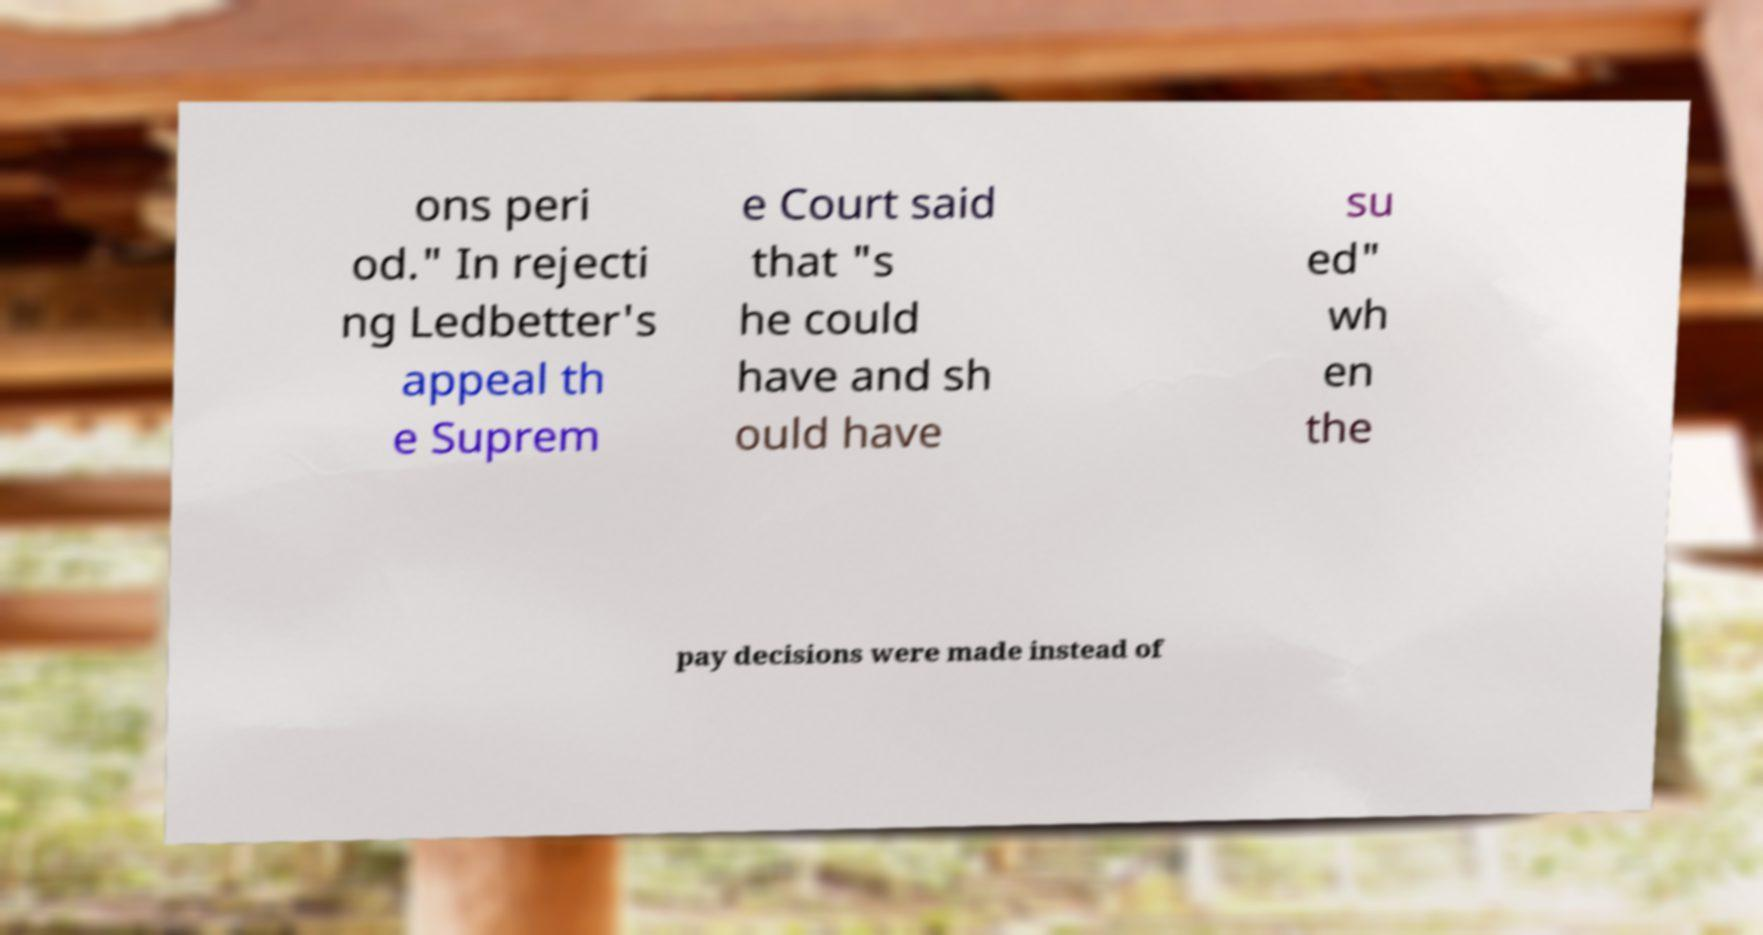Could you extract and type out the text from this image? ons peri od." In rejecti ng Ledbetter's appeal th e Suprem e Court said that "s he could have and sh ould have su ed" wh en the pay decisions were made instead of 